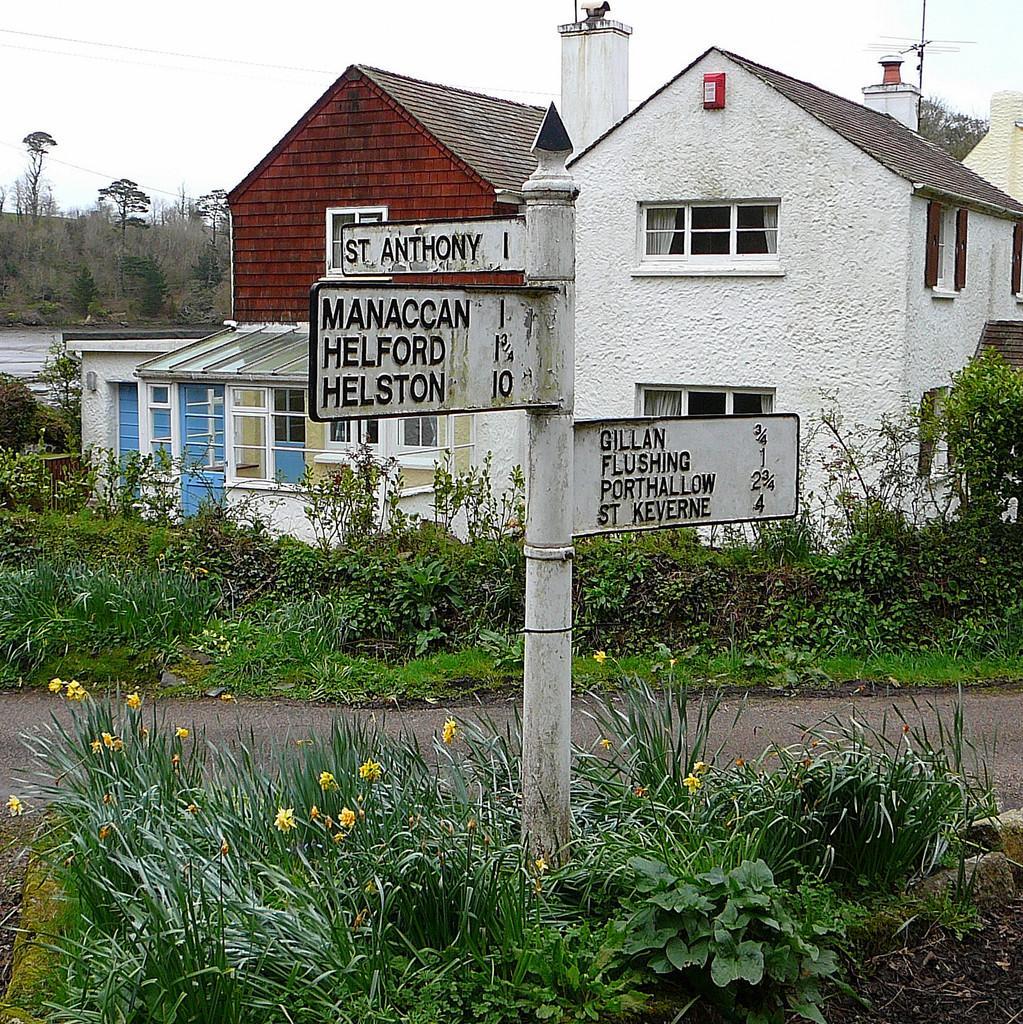Could you give a brief overview of what you see in this image? At the bottom we can see grass,plants with small flowers and a name boards pole on the ground and this is a road. In the background there are plants,grass,houses,windows,curtains,trees,electric wires,antenna,doors and sky. 